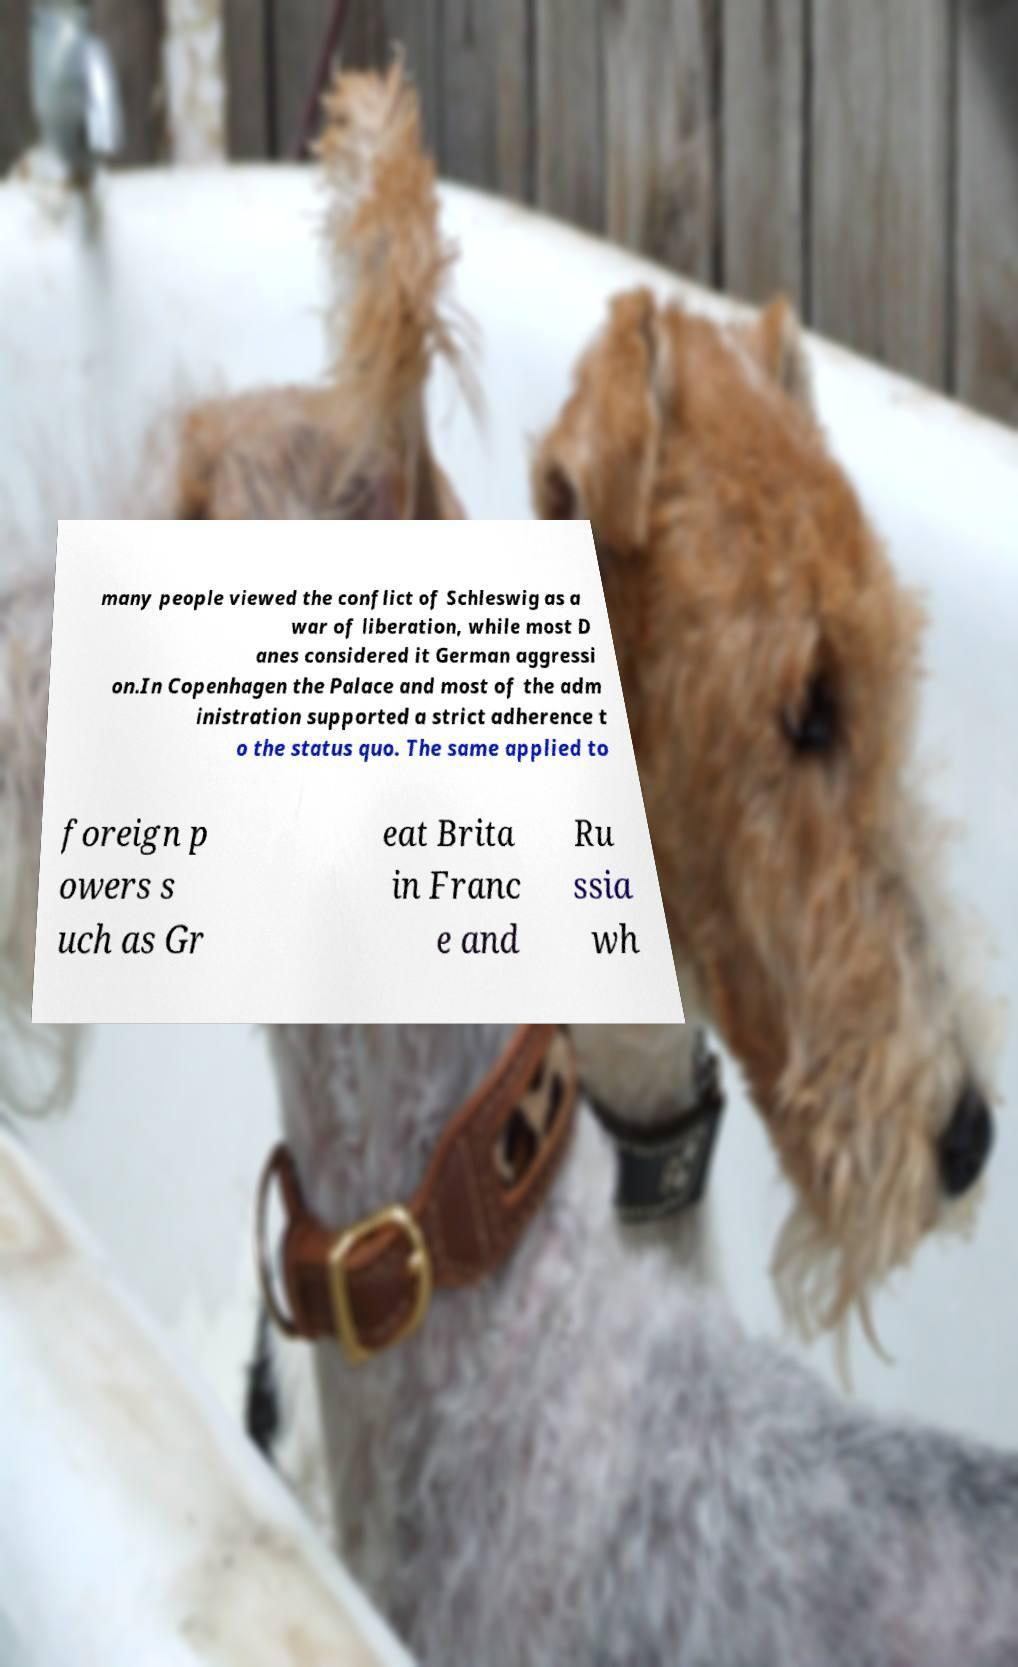Could you assist in decoding the text presented in this image and type it out clearly? many people viewed the conflict of Schleswig as a war of liberation, while most D anes considered it German aggressi on.In Copenhagen the Palace and most of the adm inistration supported a strict adherence t o the status quo. The same applied to foreign p owers s uch as Gr eat Brita in Franc e and Ru ssia wh 